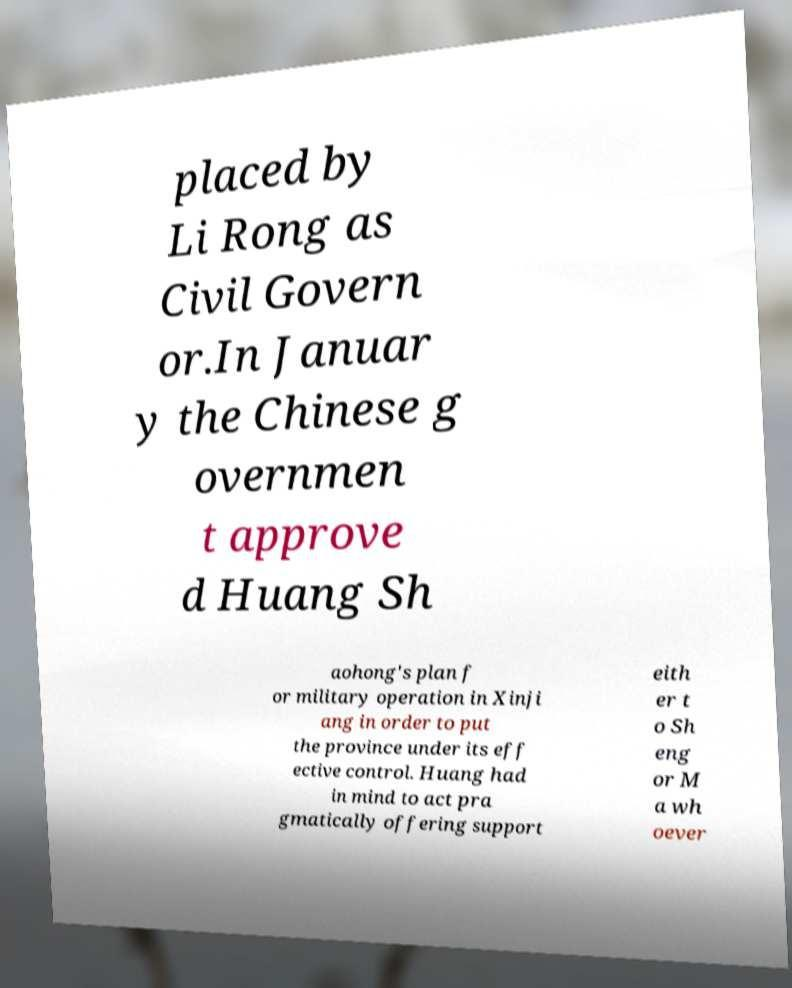Can you read and provide the text displayed in the image?This photo seems to have some interesting text. Can you extract and type it out for me? placed by Li Rong as Civil Govern or.In Januar y the Chinese g overnmen t approve d Huang Sh aohong's plan f or military operation in Xinji ang in order to put the province under its eff ective control. Huang had in mind to act pra gmatically offering support eith er t o Sh eng or M a wh oever 